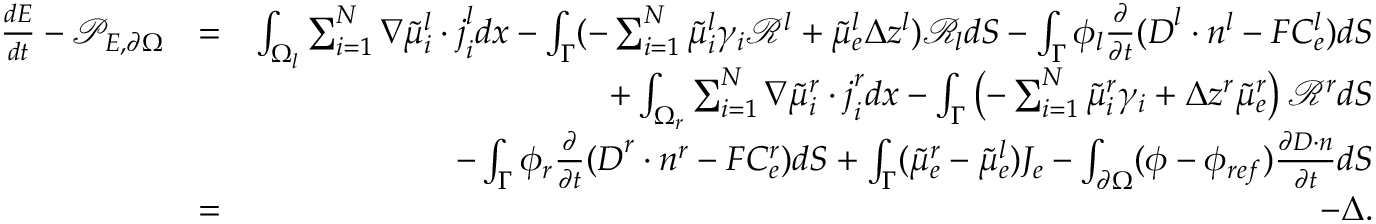<formula> <loc_0><loc_0><loc_500><loc_500>\begin{array} { r l r } { \frac { d E } { d t } - \mathcal { P } _ { E , \partial \Omega } } & { = } & { \int _ { \Omega _ { l } } \sum _ { i = 1 } ^ { N } \nabla \tilde { \mu } _ { i } ^ { l } \cdot j _ { i } ^ { l } d x - \int _ { \Gamma } ( - \sum _ { i = 1 } ^ { N } \tilde { \mu } _ { i } ^ { l } \gamma _ { i } \mathcal { R } ^ { l } + \tilde { \mu } _ { e } ^ { l } \Delta z ^ { l } ) \mathcal { R } _ { l } d S - \int _ { \Gamma } \phi _ { l } \frac { \partial } { \partial t } ( D ^ { l } \cdot n ^ { l } - F C _ { e } ^ { l } ) d S } \\ & { + \int _ { \Omega _ { r } } \sum _ { i = 1 } ^ { N } \nabla \tilde { \mu } _ { i } ^ { r } \cdot j _ { i } ^ { r } d x - \int _ { \Gamma } \left ( - \sum _ { i = 1 } ^ { N } \tilde { \mu } _ { i } ^ { r } \gamma _ { i } + \Delta z ^ { r } \tilde { \mu } _ { e } ^ { r } \right ) \mathcal { R } ^ { r } d S } \\ & { - \int _ { \Gamma } \phi _ { r } \frac { \partial } { \partial t } ( D ^ { r } \cdot n ^ { r } - F C _ { e } ^ { r } ) d S + \int _ { \Gamma } ( \tilde { \mu } _ { e } ^ { r } - \tilde { \mu } _ { e } ^ { l } ) J _ { e } - \int _ { \partial \Omega } ( \phi - \phi _ { r e f } ) \frac { \partial D \cdot n } { \partial t } d S } \\ & { = } & { - \Delta . } \end{array}</formula> 